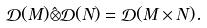<formula> <loc_0><loc_0><loc_500><loc_500>\mathcal { D } ( M ) \hat { \otimes } \mathcal { D } ( N ) = \mathcal { D } ( M \times N ) .</formula> 